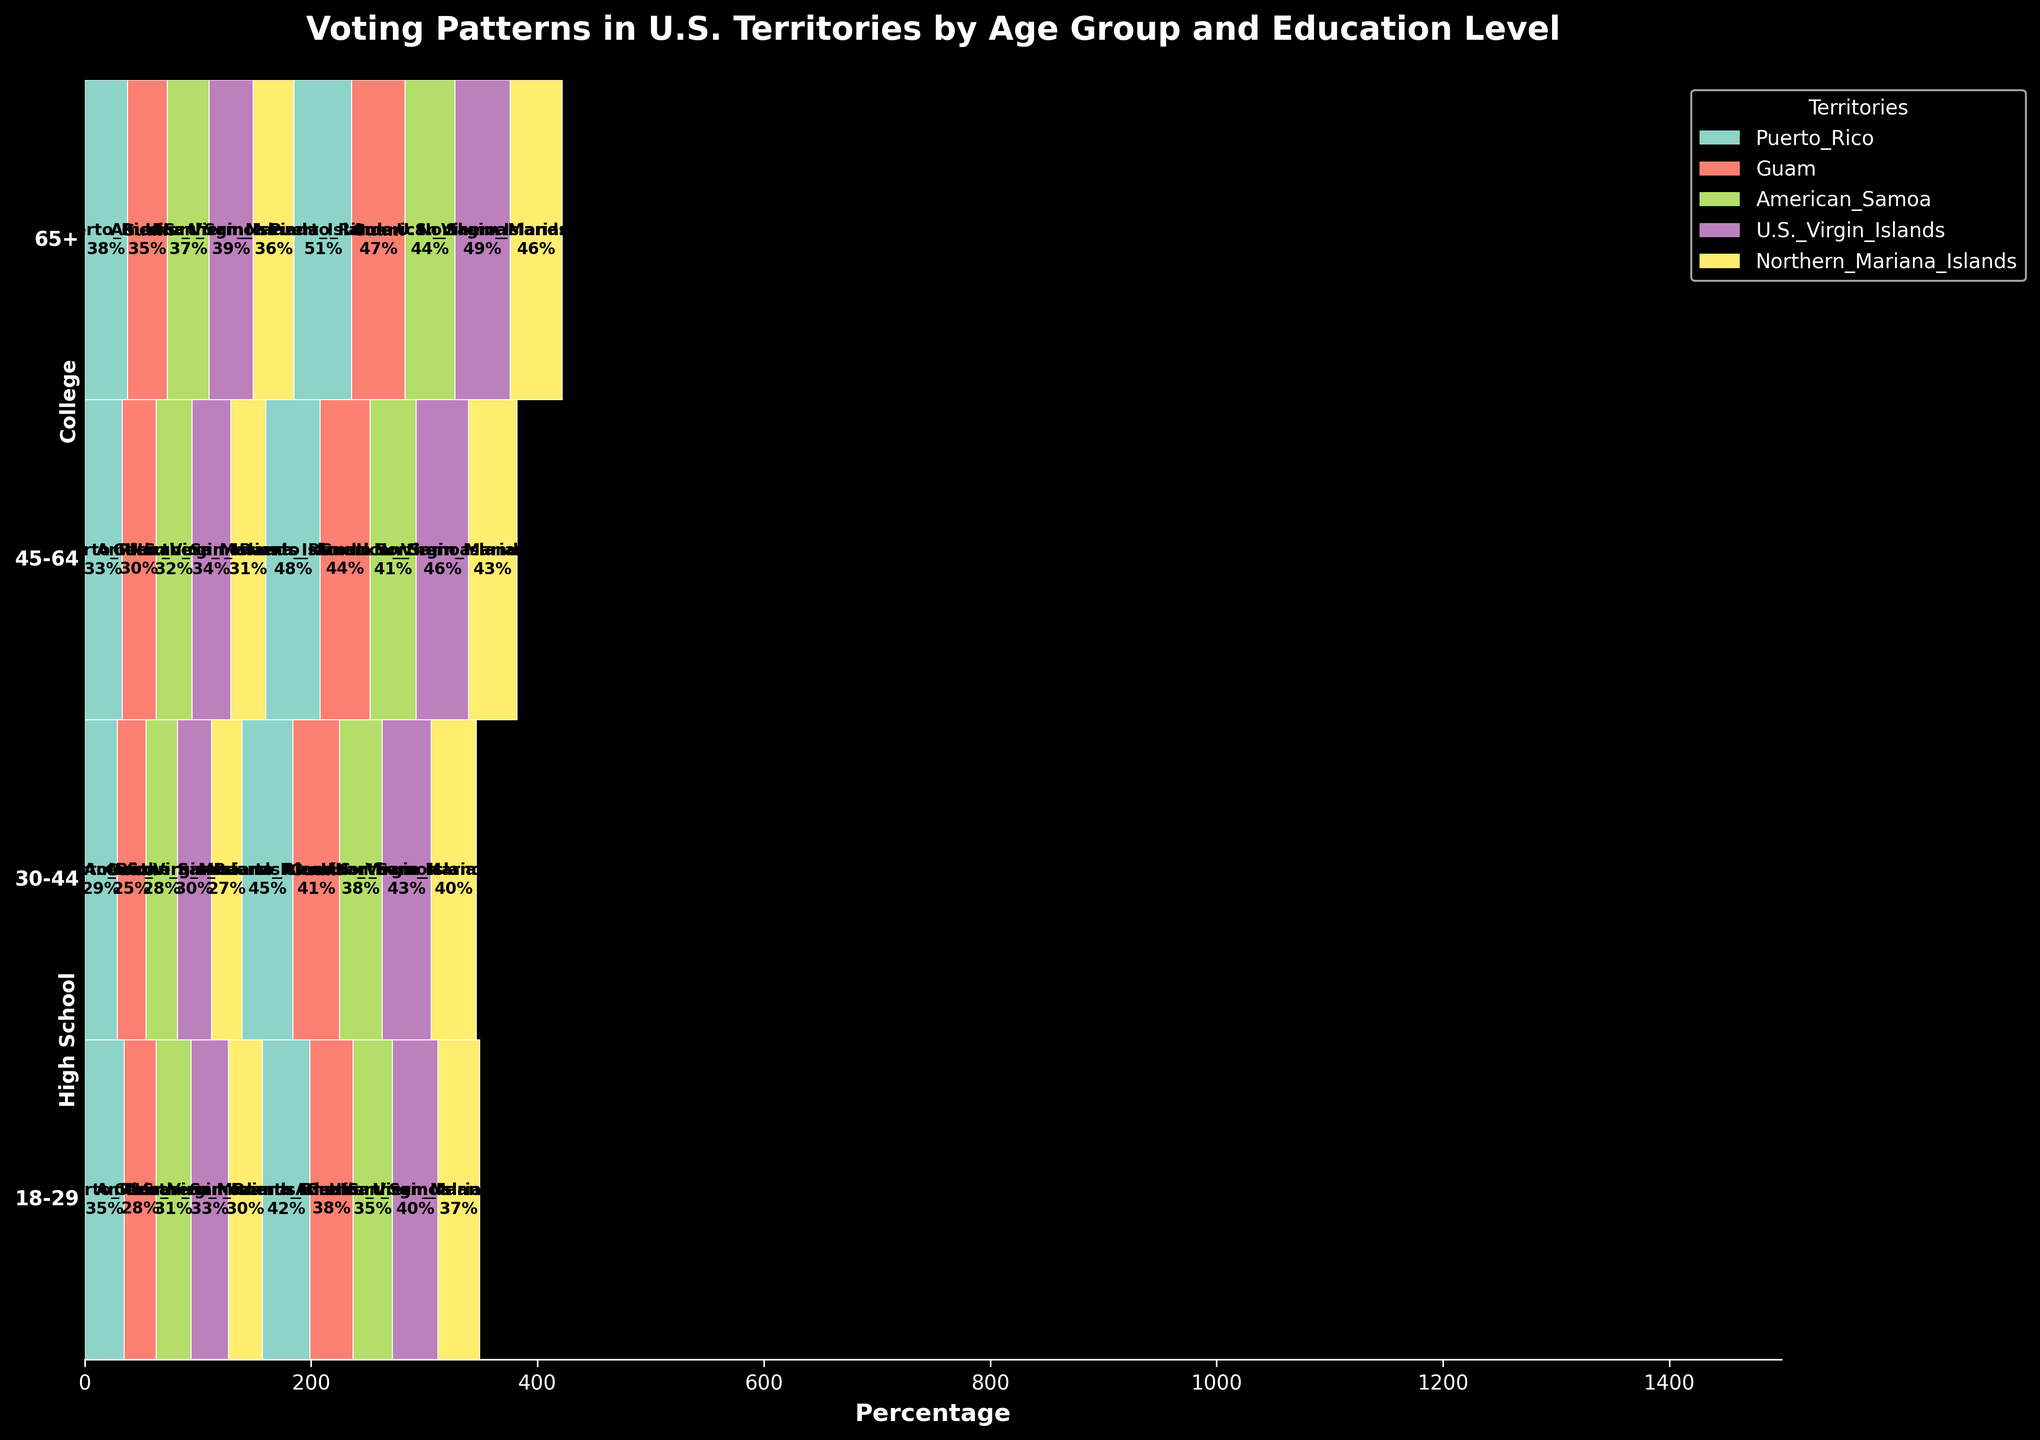What is the title of the figure? The title is usually located at the top of the plot, and it provides a concise summary of what the plot represents. In this plot, it should be clearly visible.
Answer: Voting Patterns in U.S. Territories by Age Group and Education Level How many age groups are represented in the figure? By observing the labels on the y-axis, one can easily identify and count the number of distinct age groups present.
Answer: Four Which territory has the highest voting percentage for the age group 65+ with College education? Look at the segment corresponding to 65+ and College education. Identify the largest block visually.
Answer: Puerto Rico What is the combined voting percentage for High School education across all territories for the age group 30-44? Sum the percentages of High School education for the age group 30-44 across each territory.
Answer: 139% In the 18-29 age group, does College education generally have a higher voting percentage than High School education across all territories? Compare the heights of the College and High School blocks for each territory within the 18-29 age group.
Answer: Yes Which education level appears to have a higher overall voting percentage for the age group 45-64 in American Samoa? Compare the blocks representing High School and College for American Samoa within the 45-64 age group based on their size.
Answer: College In the age group 30-44, which territory has the smallest voting percentage for College education? Compare the blocks representing College education within the 30-44 age group for each territory, and identify the smallest one.
Answer: American Samoa Do the U.S. Virgin Islands have a higher voting percentage for high school-educated voters aged 18-29 than the Northern Mariana Islands? Compare the blocks for High School education within the 18-29 age group between the U.S. Virgin Islands and the Northern Mariana Islands.
Answer: Yes What's the overall trend in voting percentages by education level as age increases? Observe the pattern across the different age groups and note whether there’s an increase or decrease in the blocks representing each education level as age increases.
Answer: College percentages increase with age, while High School percentages vary more How does the voting percentage for College-educated voters in Guam compare across different age groups? Look at the blocks for College education within each age group in Guam, and compare their sizes visually.
Answer: Increases with age 